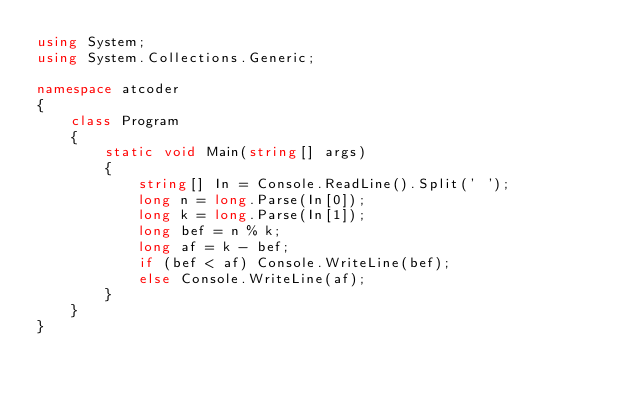Convert code to text. <code><loc_0><loc_0><loc_500><loc_500><_C#_>using System;
using System.Collections.Generic;

namespace atcoder
{
    class Program
    {
        static void Main(string[] args)
        {
            string[] In = Console.ReadLine().Split(' ');
            long n = long.Parse(In[0]);
            long k = long.Parse(In[1]);
            long bef = n % k;
            long af = k - bef;
            if (bef < af) Console.WriteLine(bef);
            else Console.WriteLine(af);
        }
    }
}
</code> 